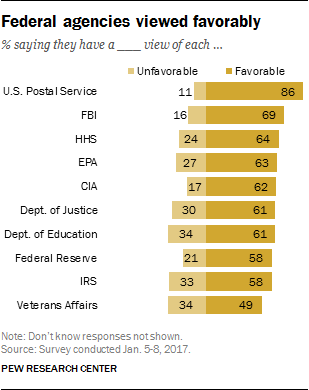Outline some significant characteristics in this image. The median value of the favorable bars is [61.5, 24.7], and the average value of the unfavorable bars is [61.5, 24.7]. The U.S. Postal Service is the most favorable Federal agency according to some individuals. 